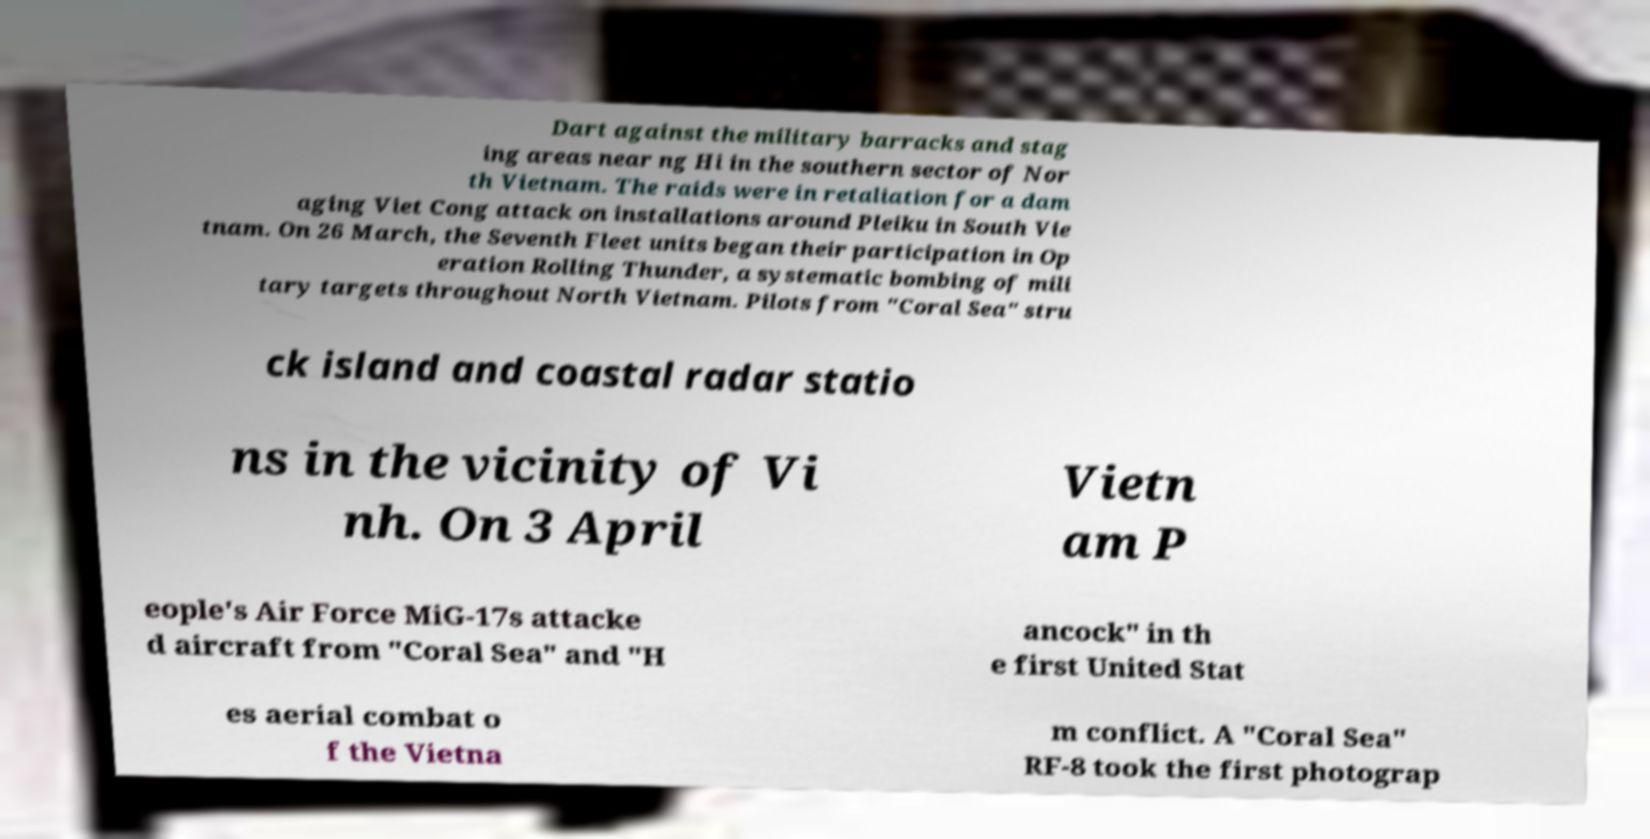Please identify and transcribe the text found in this image. Dart against the military barracks and stag ing areas near ng Hi in the southern sector of Nor th Vietnam. The raids were in retaliation for a dam aging Viet Cong attack on installations around Pleiku in South Vie tnam. On 26 March, the Seventh Fleet units began their participation in Op eration Rolling Thunder, a systematic bombing of mili tary targets throughout North Vietnam. Pilots from "Coral Sea" stru ck island and coastal radar statio ns in the vicinity of Vi nh. On 3 April Vietn am P eople's Air Force MiG-17s attacke d aircraft from "Coral Sea" and "H ancock" in th e first United Stat es aerial combat o f the Vietna m conflict. A "Coral Sea" RF-8 took the first photograp 